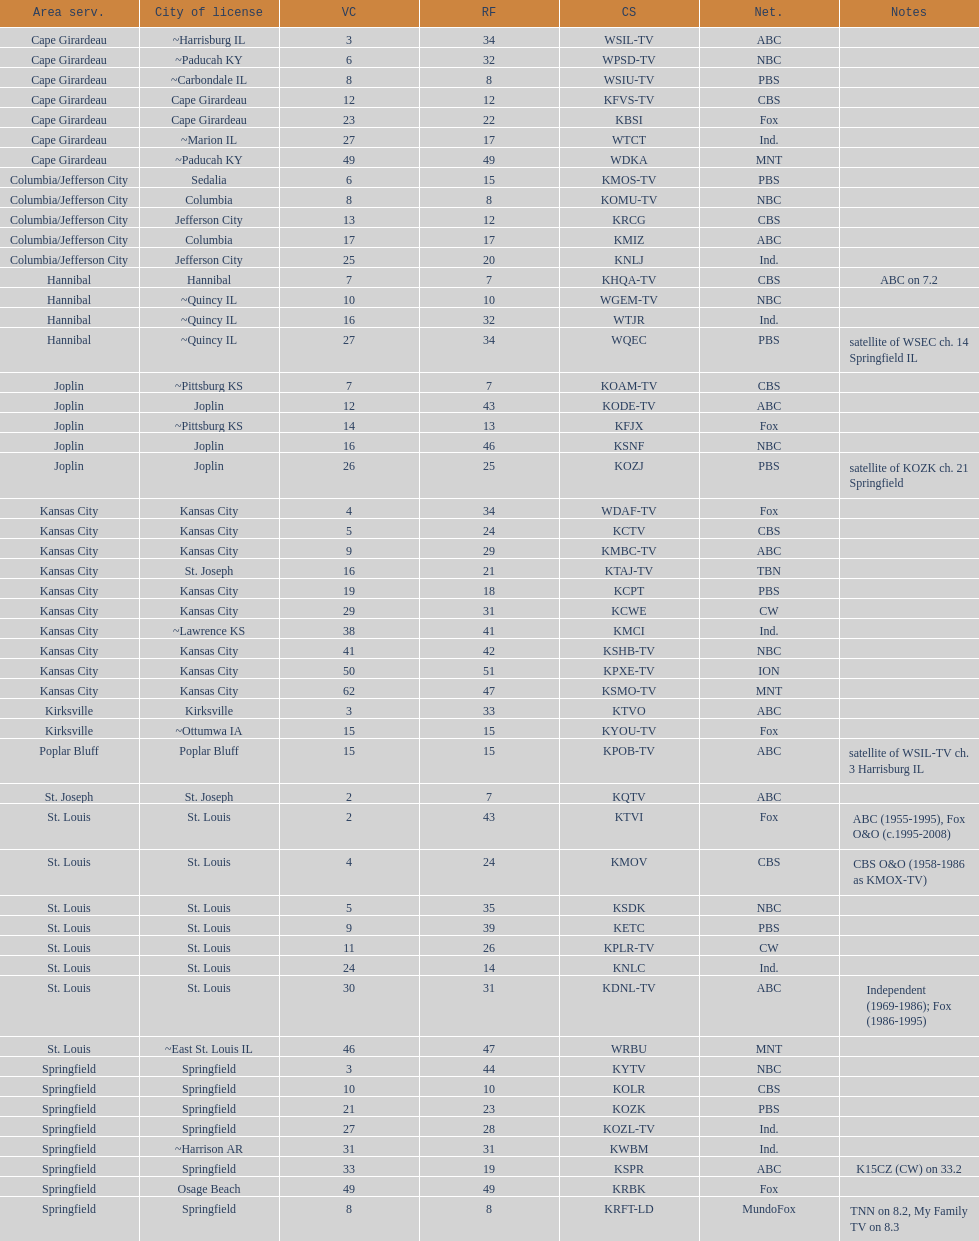What is the total number of cbs stations? 7. 